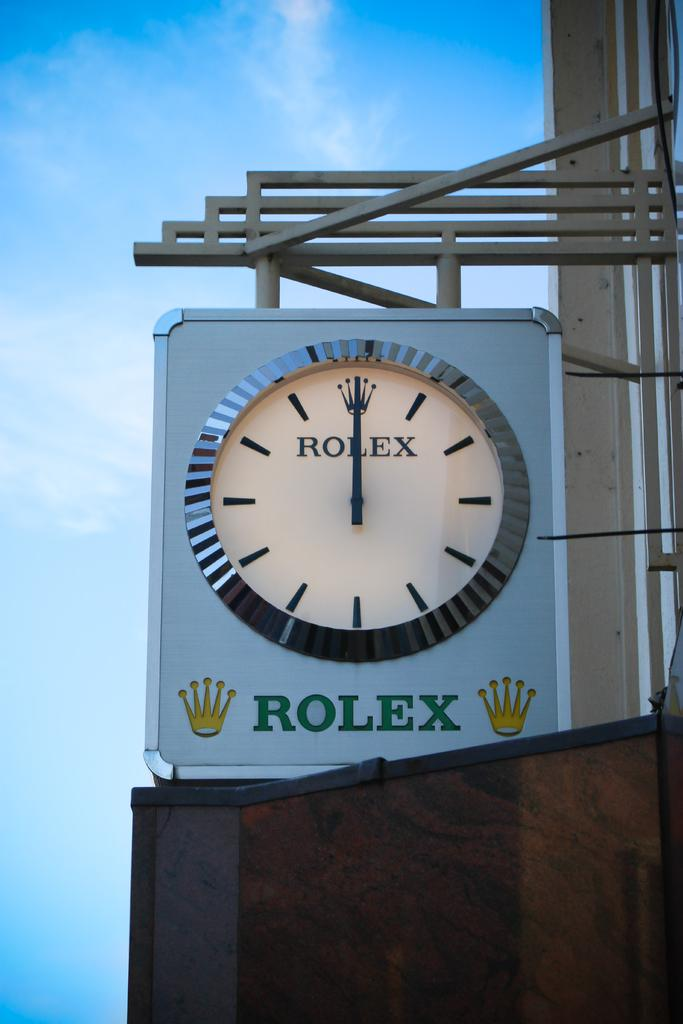<image>
Write a terse but informative summary of the picture. A large exterior clock with the brand Rolex written prominently across the front. 